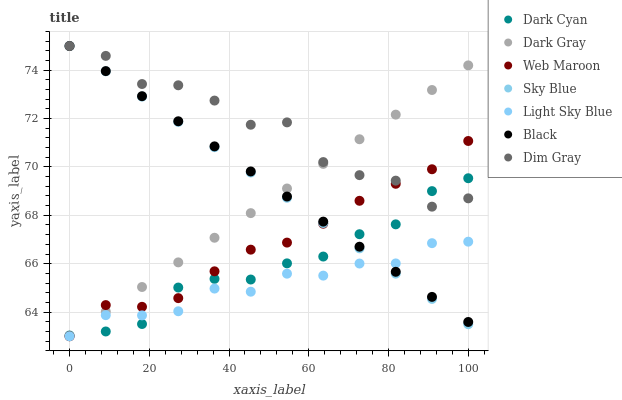Does Light Sky Blue have the minimum area under the curve?
Answer yes or no. Yes. Does Dim Gray have the maximum area under the curve?
Answer yes or no. Yes. Does Web Maroon have the minimum area under the curve?
Answer yes or no. No. Does Web Maroon have the maximum area under the curve?
Answer yes or no. No. Is Dark Gray the smoothest?
Answer yes or no. Yes. Is Dim Gray the roughest?
Answer yes or no. Yes. Is Web Maroon the smoothest?
Answer yes or no. No. Is Web Maroon the roughest?
Answer yes or no. No. Does Web Maroon have the lowest value?
Answer yes or no. Yes. Does Black have the lowest value?
Answer yes or no. No. Does Sky Blue have the highest value?
Answer yes or no. Yes. Does Web Maroon have the highest value?
Answer yes or no. No. Is Light Sky Blue less than Dim Gray?
Answer yes or no. Yes. Is Dim Gray greater than Light Sky Blue?
Answer yes or no. Yes. Does Sky Blue intersect Dark Gray?
Answer yes or no. Yes. Is Sky Blue less than Dark Gray?
Answer yes or no. No. Is Sky Blue greater than Dark Gray?
Answer yes or no. No. Does Light Sky Blue intersect Dim Gray?
Answer yes or no. No. 